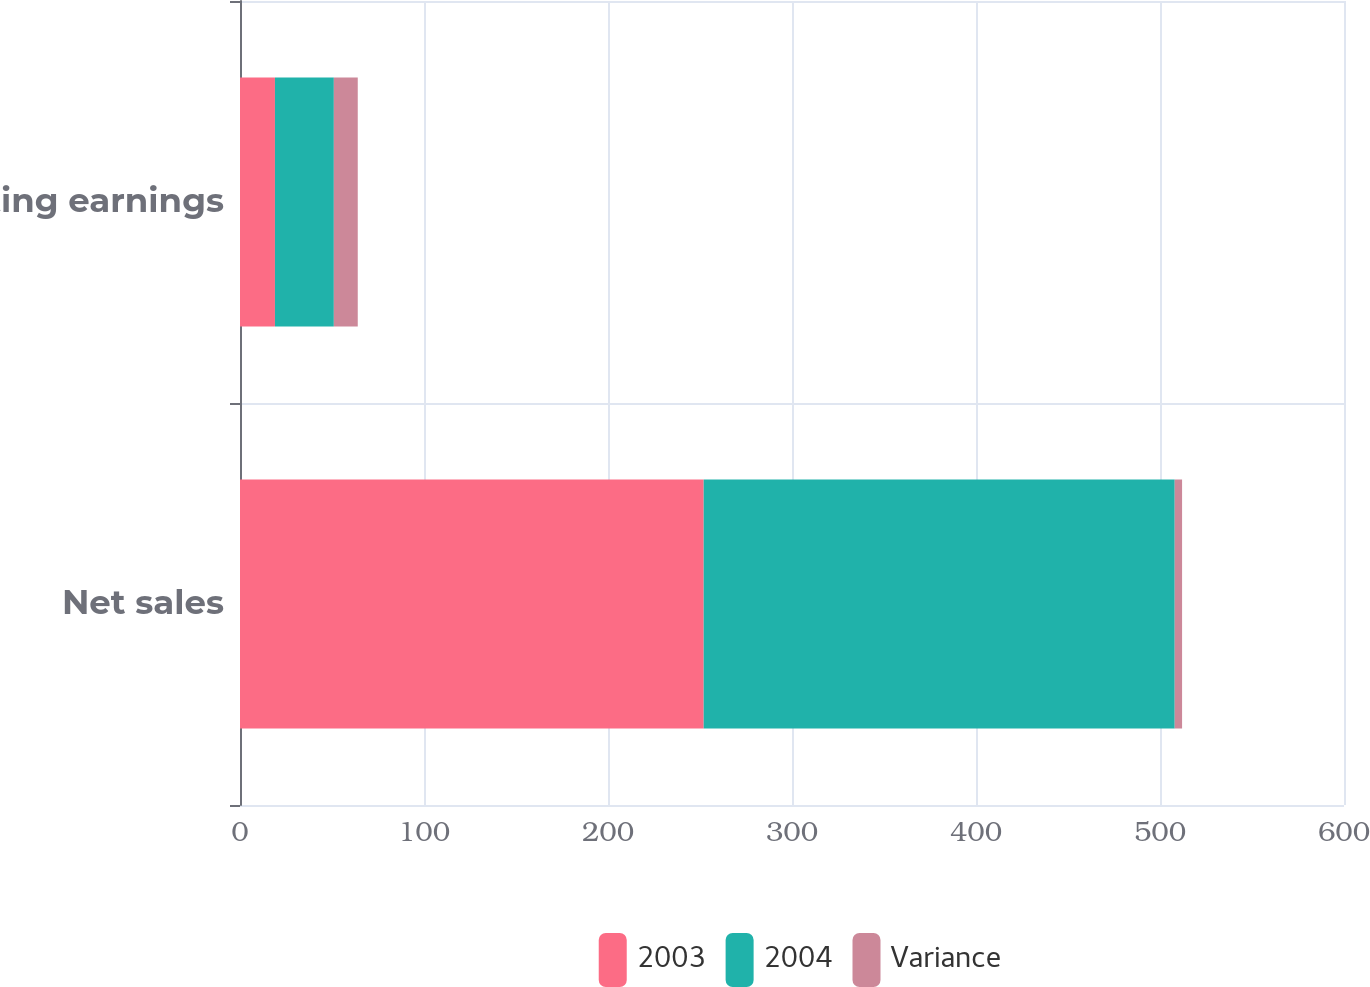Convert chart to OTSL. <chart><loc_0><loc_0><loc_500><loc_500><stacked_bar_chart><ecel><fcel>Net sales<fcel>Operating earnings<nl><fcel>2003<fcel>252<fcel>19<nl><fcel>2004<fcel>256<fcel>32<nl><fcel>Variance<fcel>4<fcel>13<nl></chart> 